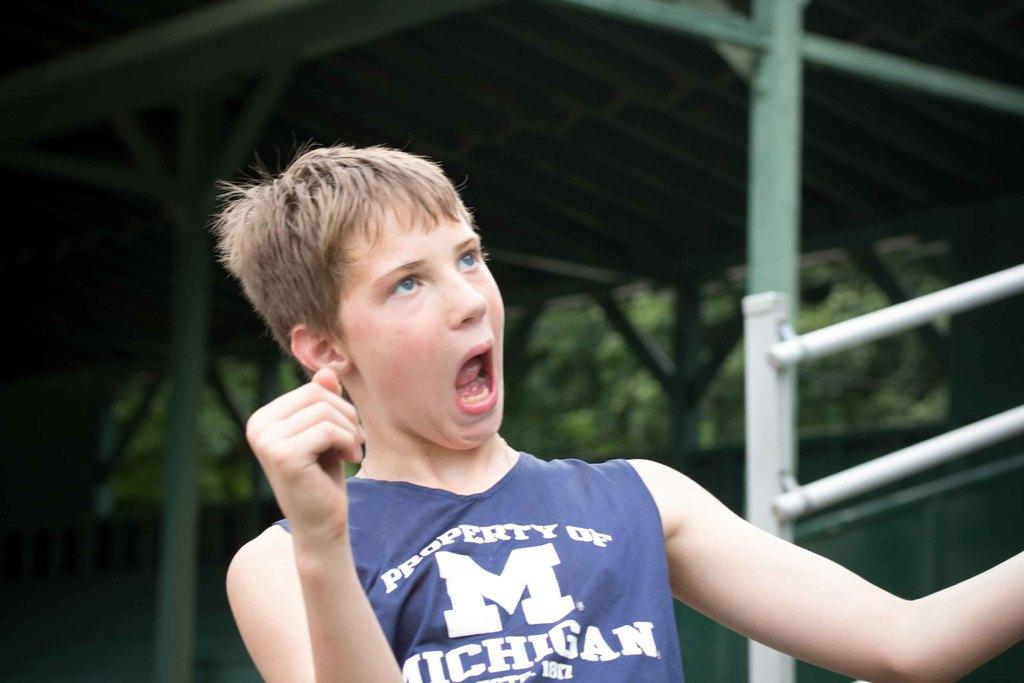Provide a one-sentence caption for the provided image. A male is wearing a "Property of Michigan" jersey and making a funny face. 